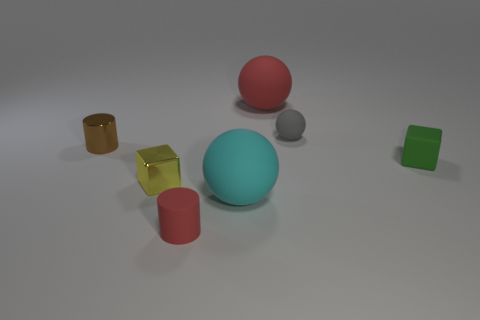Add 3 small yellow cylinders. How many objects exist? 10 Subtract all cubes. How many objects are left? 5 Subtract 0 brown blocks. How many objects are left? 7 Subtract all cyan rubber spheres. Subtract all big cyan matte spheres. How many objects are left? 5 Add 5 red rubber cylinders. How many red rubber cylinders are left? 6 Add 1 tiny yellow shiny objects. How many tiny yellow shiny objects exist? 2 